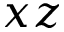<formula> <loc_0><loc_0><loc_500><loc_500>x z</formula> 